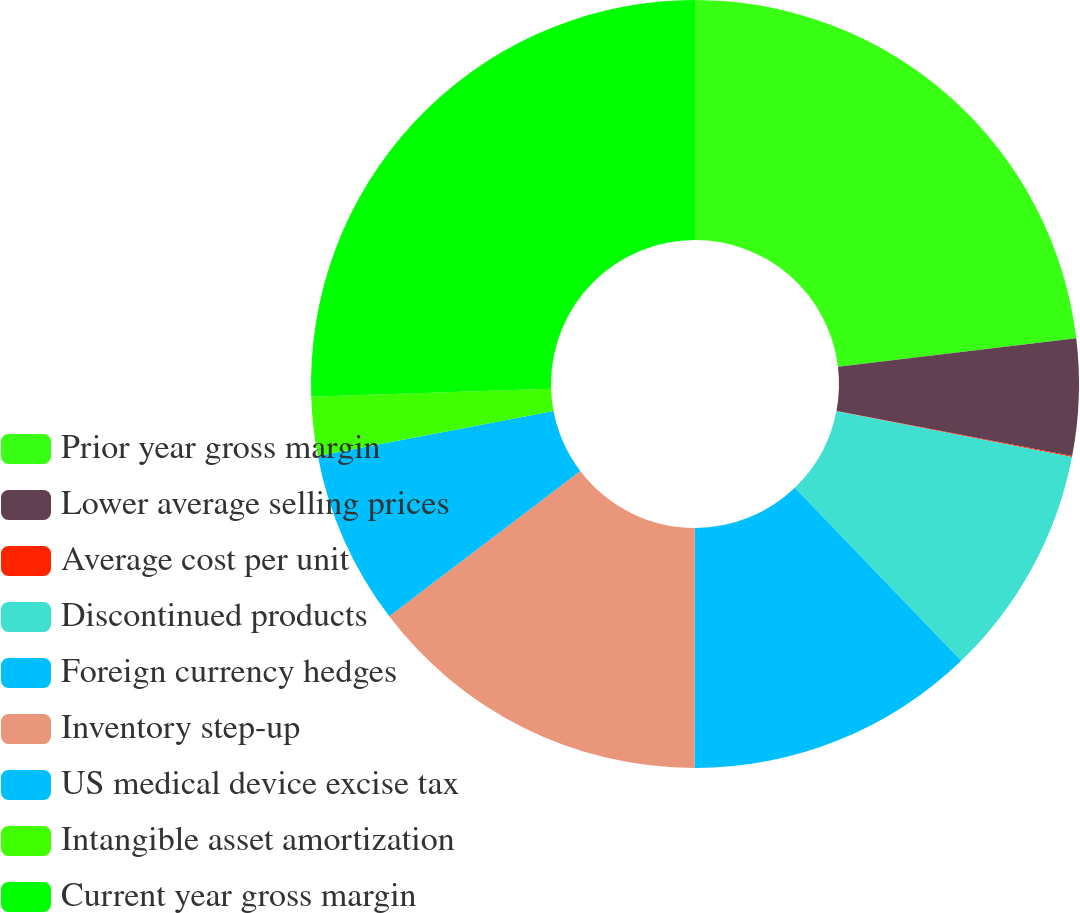Convert chart. <chart><loc_0><loc_0><loc_500><loc_500><pie_chart><fcel>Prior year gross margin<fcel>Lower average selling prices<fcel>Average cost per unit<fcel>Discontinued products<fcel>Foreign currency hedges<fcel>Inventory step-up<fcel>US medical device excise tax<fcel>Intangible asset amortization<fcel>Current year gross margin<nl><fcel>23.1%<fcel>4.9%<fcel>0.04%<fcel>9.77%<fcel>12.21%<fcel>14.64%<fcel>7.34%<fcel>2.47%<fcel>25.53%<nl></chart> 